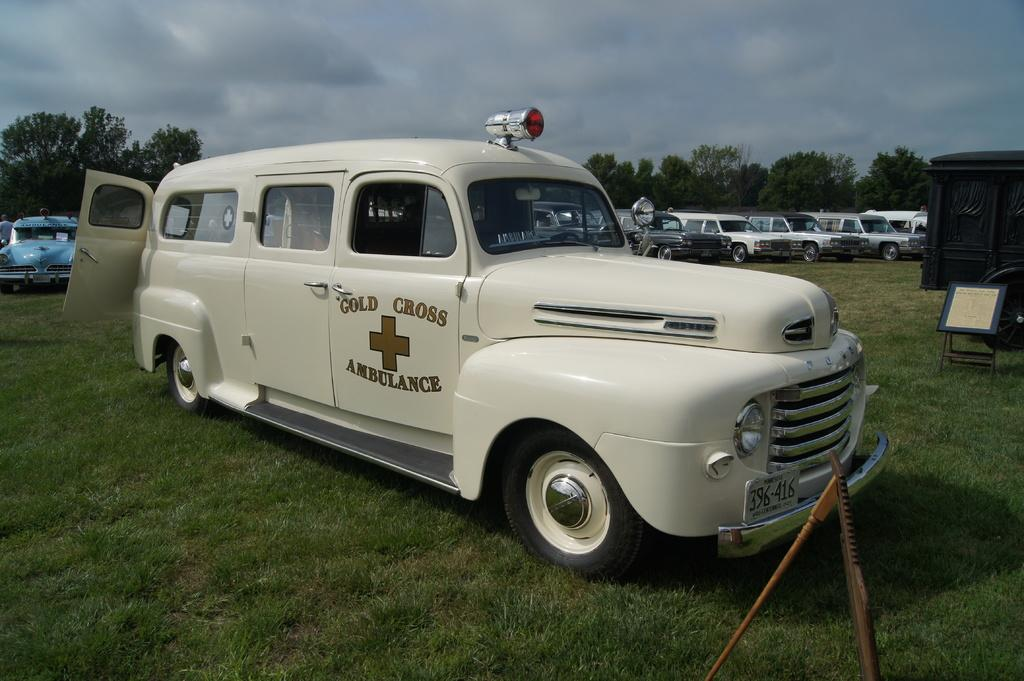<image>
Summarize the visual content of the image. An antique gold cross ambulance is parked on grass with other old vehicles parked behind it. 